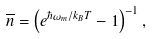Convert formula to latex. <formula><loc_0><loc_0><loc_500><loc_500>\overline { n } = \left ( e ^ { \hbar { \omega } _ { m } / k _ { B } T } - 1 \right ) ^ { - 1 } ,</formula> 